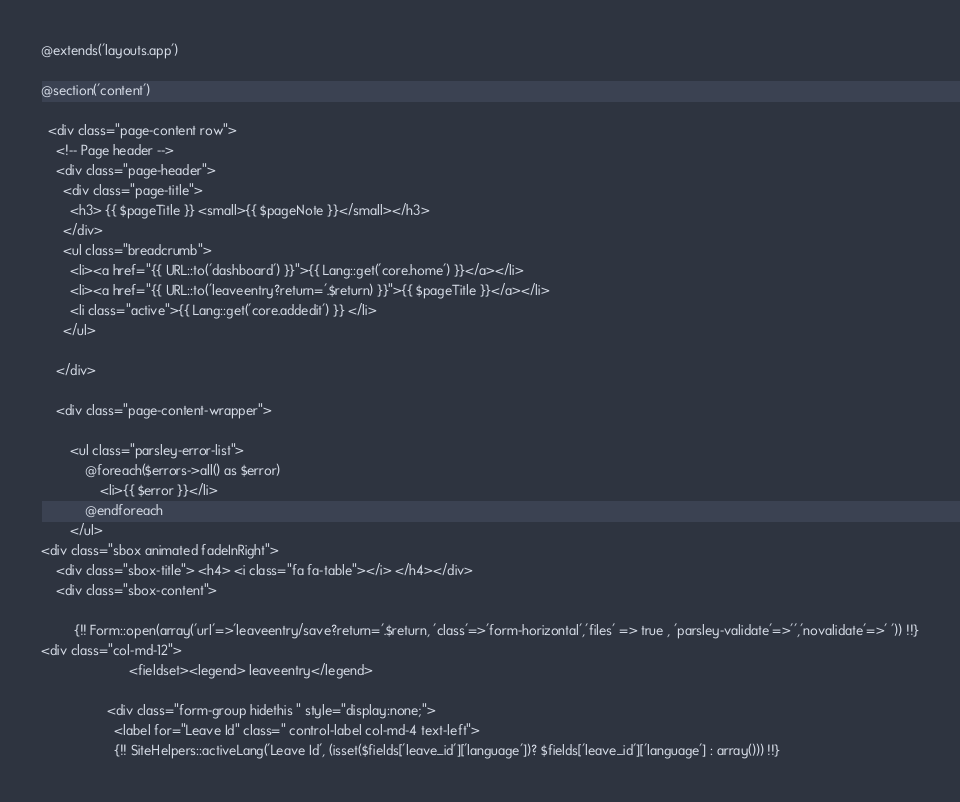Convert code to text. <code><loc_0><loc_0><loc_500><loc_500><_PHP_>@extends('layouts.app')

@section('content')

  <div class="page-content row">
    <!-- Page header -->
    <div class="page-header">
      <div class="page-title">
        <h3> {{ $pageTitle }} <small>{{ $pageNote }}</small></h3>
      </div>
      <ul class="breadcrumb">
        <li><a href="{{ URL::to('dashboard') }}">{{ Lang::get('core.home') }}</a></li>
		<li><a href="{{ URL::to('leaveentry?return='.$return) }}">{{ $pageTitle }}</a></li>
        <li class="active">{{ Lang::get('core.addedit') }} </li>
      </ul>
	  	  
    </div>
 
 	<div class="page-content-wrapper">

		<ul class="parsley-error-list">
			@foreach($errors->all() as $error)
				<li>{{ $error }}</li>
			@endforeach
		</ul>
<div class="sbox animated fadeInRight">
	<div class="sbox-title"> <h4> <i class="fa fa-table"></i> </h4></div>
	<div class="sbox-content"> 	

		 {!! Form::open(array('url'=>'leaveentry/save?return='.$return, 'class'=>'form-horizontal','files' => true , 'parsley-validate'=>'','novalidate'=>' ')) !!}
<div class="col-md-12">
						<fieldset><legend> leaveentry</legend>
									
				  <div class="form-group hidethis " style="display:none;"> 
					<label for="Leave Id" class=" control-label col-md-4 text-left"> 
					{!! SiteHelpers::activeLang('Leave Id', (isset($fields['leave_id']['language'])? $fields['leave_id']['language'] : array())) !!}	</code> 